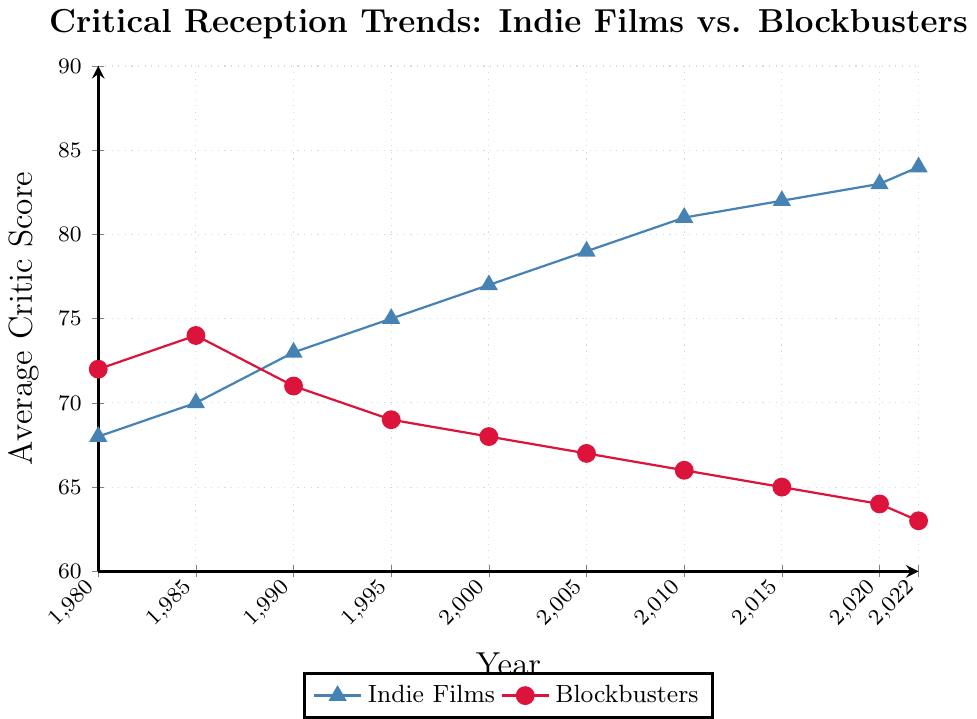What's the difference in average critic scores between indie films and blockbusters in 2022? The average critic score for indie films in 2022 is 84, and for blockbusters, it's 63. The difference is calculated as 84 - 63.
Answer: 21 Between which years did indie films see the greatest increase in average critic scores? Looking at the points on the line for indie films, the greatest increase is from 2000 to 2005, where the score rises from 77 to 79, an increase of 2 points.
Answer: 2000-2005 In what year did blockbusters have a higher average critic score than indie films? Reviewing the chart, blockbusters had higher average critic scores than indie films in 1980 and 1985.
Answer: 1980, 1985 How much did the average critic score for blockbusters decrease from 1990 to 2022? The average critic score for blockbusters in 1990 was 71, and it dropped to 63 by 2022. The decrease is calculated as 71 - 63.
Answer: 8 Did indie films ever receive an average critic score below 70? Examining the chart, the lowest average score for indie films is 68 in 1980.
Answer: Yes What's the average increase in scores for indie films per decade from 1980 to 2020? Calculate the increase in each decade: 1980-1990: 5 points, 1990-2000: 4 points, 2000-2010: 4 points, 2010-2020: 2 points. Sum these increases (5 + 4 + 4 + 2 = 15) and divide by the number of decades (4).
Answer: 3.75 In which year did indie films and blockbusters have the smallest difference in average critic scores? Compare the difference for each year: 1980 (4), 1985 (4), 1990 (2), 1995 (6), 2000 (9), 2005 (12), 2010 (15), 2015 (17), 2020 (19), and 2022 (21). The smallest difference is in 1990.
Answer: 1990 Which type of film had a more consistent trend in critic scores from 1980 to 2022? Indie films show a consistent upward trend, whereas blockbusters show a consistent downward trend. Consistency here is interpreted as a clear progressional change without reversals.
Answer: Both, but in opposite directions What's the overall trend for blockbusters' average critic scores? From 1980 to 2022, blockbusters' scores consistently decrease from a high of 74 in 1985 to a low of 63 in 2022.
Answer: Decreasing By how many points did indie films' average critic scores increase from the lowest recorded score to the highest? The lowest score for indie films is 68 in 1980, and the highest is 84 in 2022. The increase is 84 - 68.
Answer: 16 